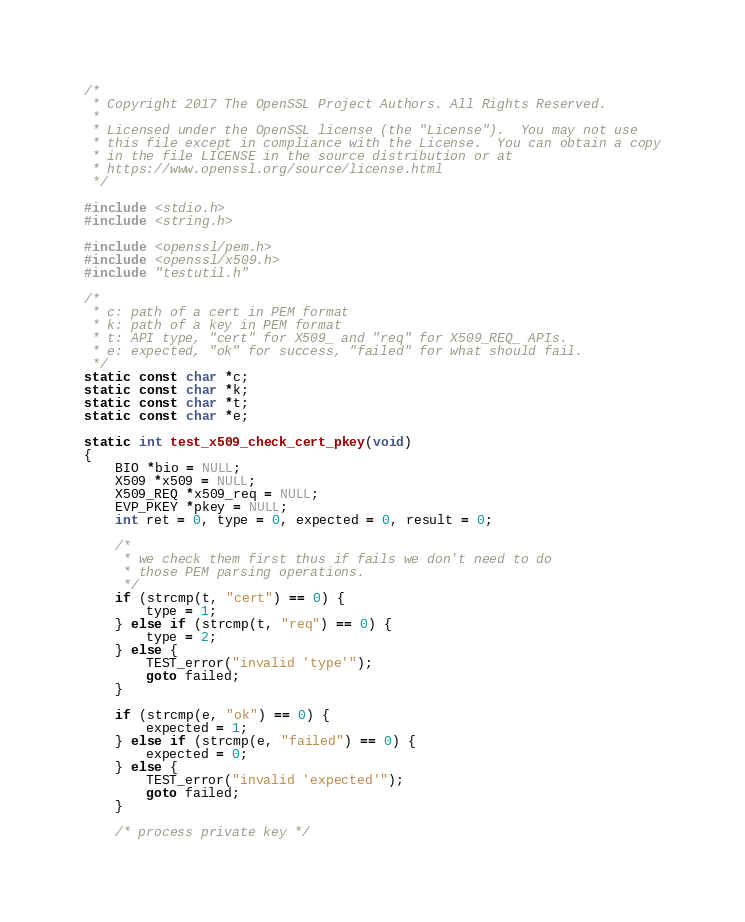Convert code to text. <code><loc_0><loc_0><loc_500><loc_500><_C_>/*
 * Copyright 2017 The OpenSSL Project Authors. All Rights Reserved.
 *
 * Licensed under the OpenSSL license (the "License").  You may not use
 * this file except in compliance with the License.  You can obtain a copy
 * in the file LICENSE in the source distribution or at
 * https://www.openssl.org/source/license.html
 */

#include <stdio.h>
#include <string.h>

#include <openssl/pem.h>
#include <openssl/x509.h>
#include "testutil.h"

/*
 * c: path of a cert in PEM format
 * k: path of a key in PEM format
 * t: API type, "cert" for X509_ and "req" for X509_REQ_ APIs.
 * e: expected, "ok" for success, "failed" for what should fail.
 */
static const char *c;
static const char *k;
static const char *t;
static const char *e;

static int test_x509_check_cert_pkey(void)
{
    BIO *bio = NULL;
    X509 *x509 = NULL;
    X509_REQ *x509_req = NULL;
    EVP_PKEY *pkey = NULL;
    int ret = 0, type = 0, expected = 0, result = 0;

    /*
     * we check them first thus if fails we don't need to do
     * those PEM parsing operations.
     */
    if (strcmp(t, "cert") == 0) {
        type = 1;
    } else if (strcmp(t, "req") == 0) {
        type = 2;
    } else {
        TEST_error("invalid 'type'");
        goto failed;
    }

    if (strcmp(e, "ok") == 0) {
        expected = 1;
    } else if (strcmp(e, "failed") == 0) {
        expected = 0;
    } else {
        TEST_error("invalid 'expected'");
        goto failed;
    }

    /* process private key */</code> 